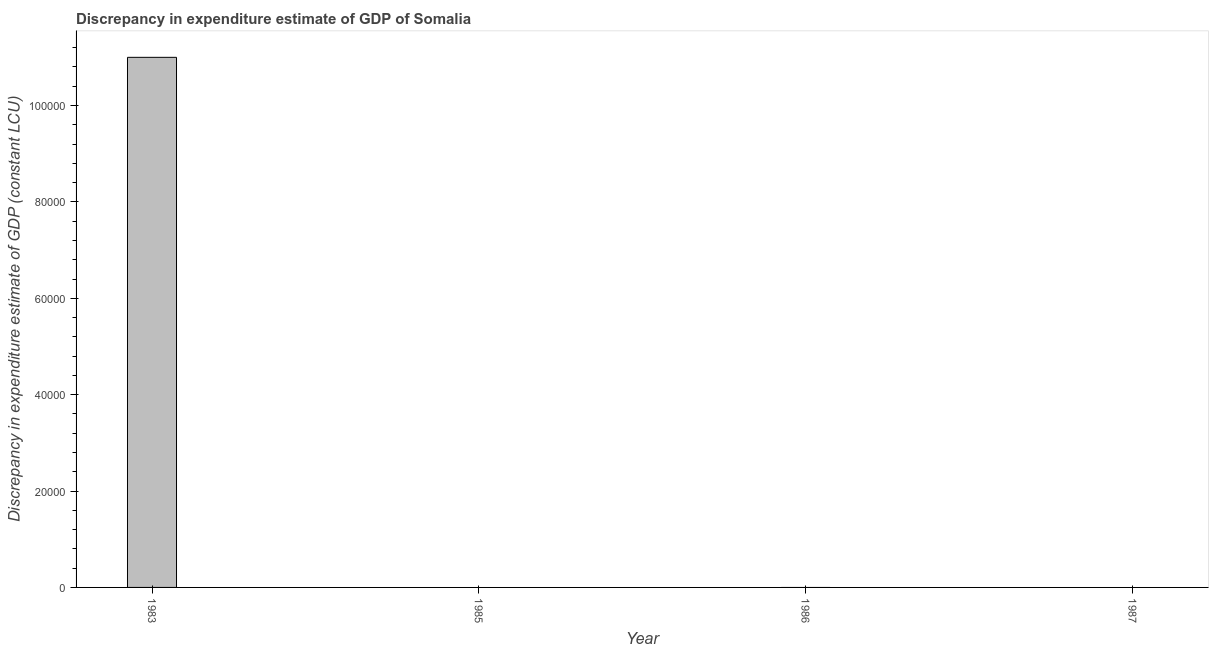Does the graph contain grids?
Provide a succinct answer. No. What is the title of the graph?
Keep it short and to the point. Discrepancy in expenditure estimate of GDP of Somalia. What is the label or title of the X-axis?
Ensure brevity in your answer.  Year. What is the label or title of the Y-axis?
Provide a succinct answer. Discrepancy in expenditure estimate of GDP (constant LCU). Across all years, what is the minimum discrepancy in expenditure estimate of gdp?
Make the answer very short. 0. In which year was the discrepancy in expenditure estimate of gdp maximum?
Provide a succinct answer. 1983. What is the average discrepancy in expenditure estimate of gdp per year?
Give a very brief answer. 2.75e+04. In how many years, is the discrepancy in expenditure estimate of gdp greater than 40000 LCU?
Ensure brevity in your answer.  1. What is the difference between the highest and the lowest discrepancy in expenditure estimate of gdp?
Offer a very short reply. 1.10e+05. In how many years, is the discrepancy in expenditure estimate of gdp greater than the average discrepancy in expenditure estimate of gdp taken over all years?
Offer a very short reply. 1. Are all the bars in the graph horizontal?
Your answer should be very brief. No. Are the values on the major ticks of Y-axis written in scientific E-notation?
Provide a short and direct response. No. What is the Discrepancy in expenditure estimate of GDP (constant LCU) in 1983?
Give a very brief answer. 1.10e+05. What is the Discrepancy in expenditure estimate of GDP (constant LCU) in 1985?
Your response must be concise. 0. 